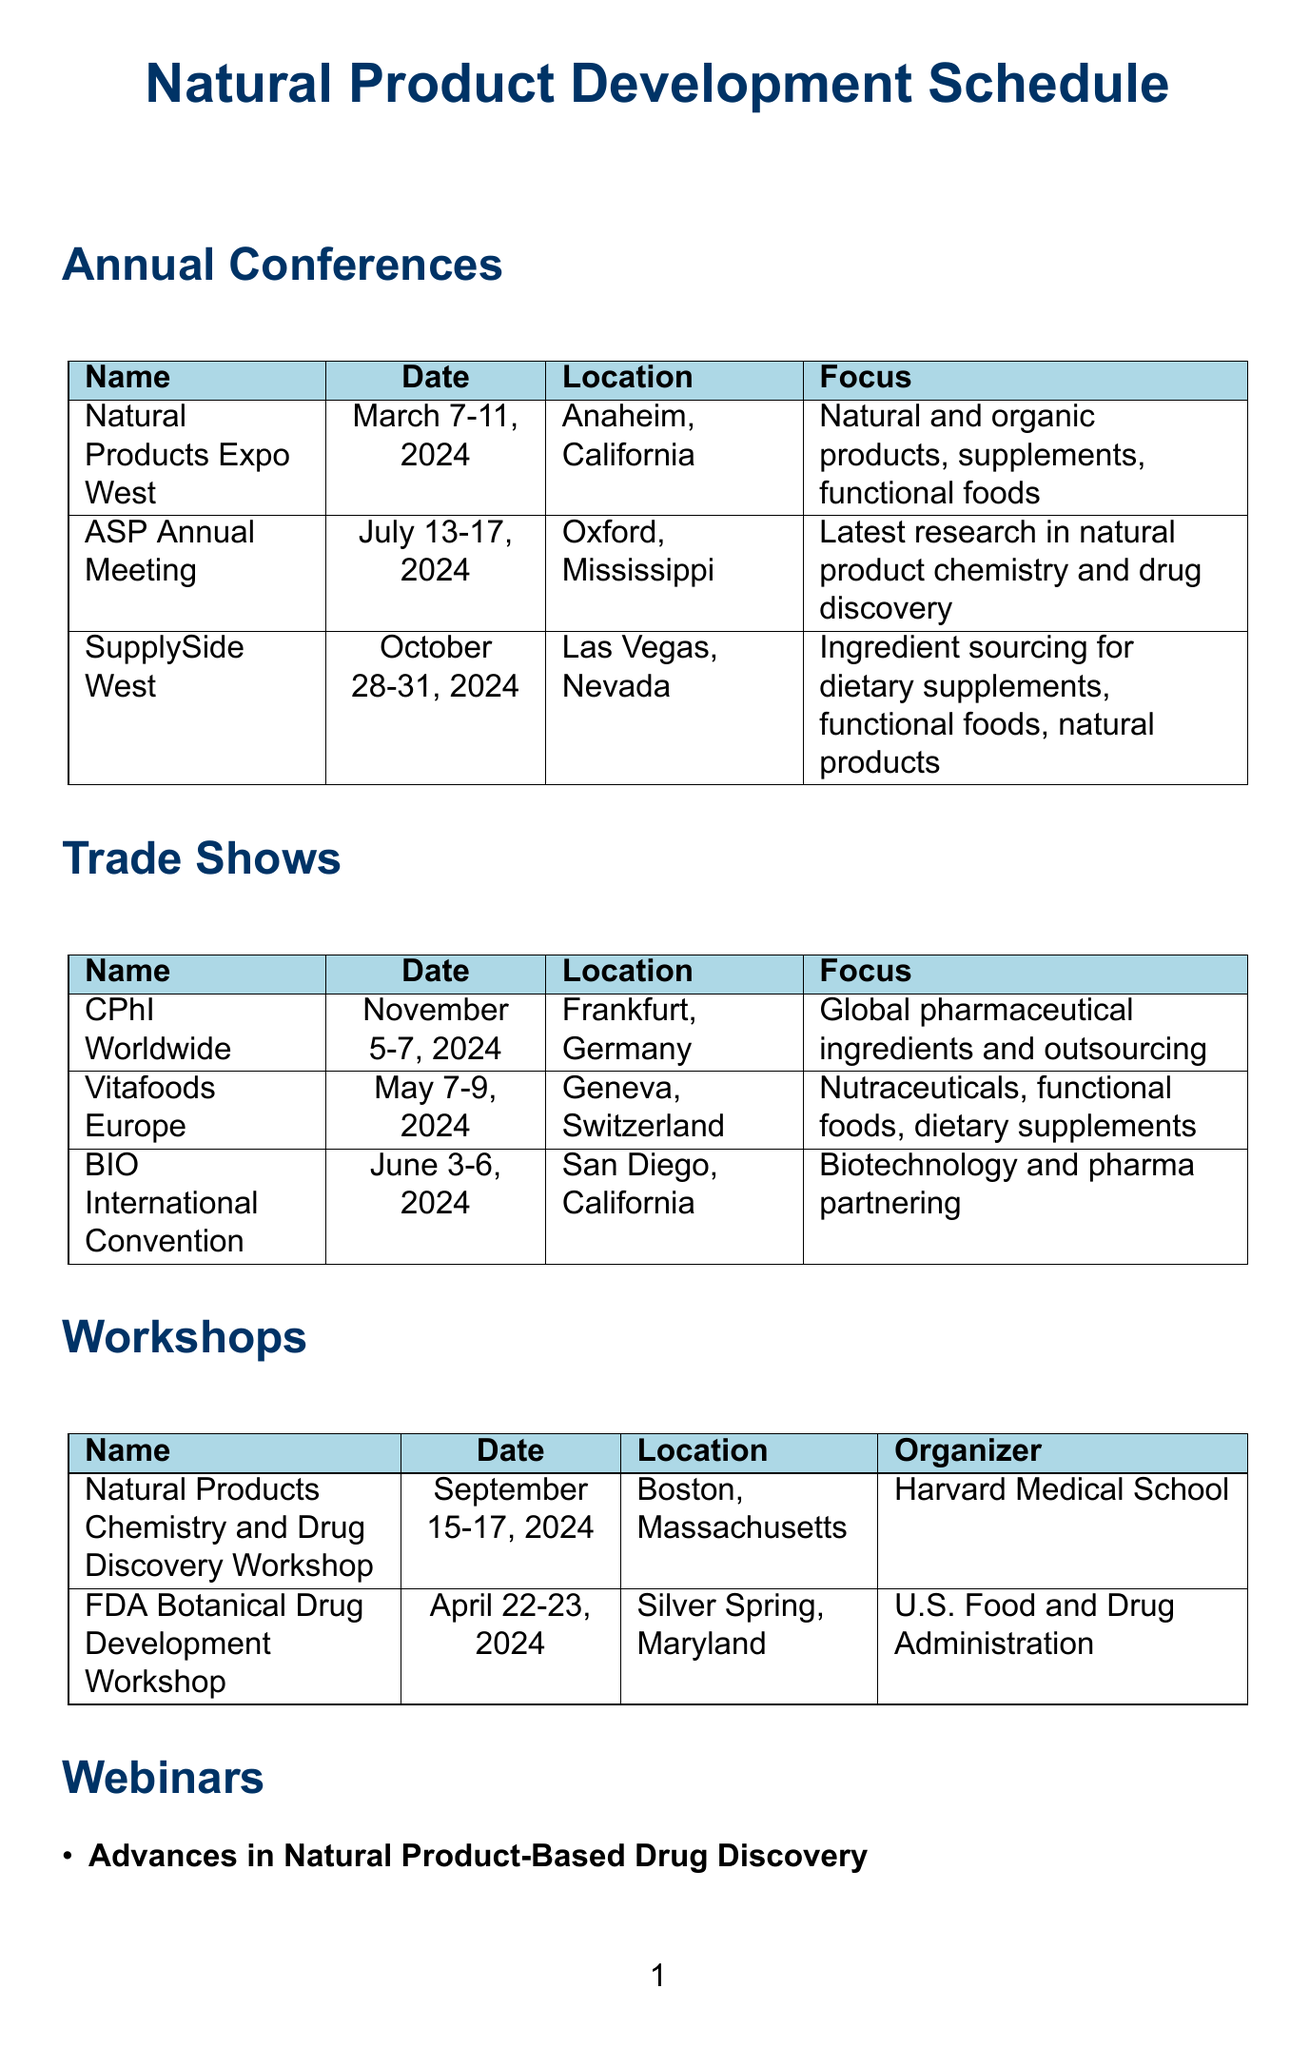What is the date for the Natural Products Expo West? The date for the Natural Products Expo West is specified in the schedule as March 7-11, 2024.
Answer: March 7-11, 2024 Where is the FDA Botanical Drug Development Workshop held? The document states that the FDA Botanical Drug Development Workshop will take place in Silver Spring, Maryland.
Answer: Silver Spring, Maryland What is the main focus of the SupplySide West? The focus of SupplySide West is described in the document as ingredient sourcing for dietary supplements, functional foods, and natural products.
Answer: Ingredient sourcing for dietary supplements, functional foods, and natural products Which organization is hosting the Natural Products Chemistry and Drug Discovery Workshop? The document indicates that Harvard Medical School is the organizer of the Natural Products Chemistry and Drug Discovery Workshop.
Answer: Harvard Medical School How often is the webinar on Advances in Natural Product-Based Drug Discovery held? The schedule specifies that the webinar on Advances in Natural Product-Based Drug Discovery is held monthly, on the last Thursday.
Answer: Monthly, last Thursday What is the location for the BIO International Convention? The document states that the BIO International Convention will take place in San Diego, California.
Answer: San Diego, California How many annual conferences are listed in the document? The document lists a total of three annual conferences.
Answer: Three What is the primary relevance of Vitafoods Europe? The document describes the relevance of Vitafoods Europe as important for exploring natural ingredients with potential pharmaceutical applications.
Answer: Important for exploring natural ingredients with potential pharmaceutical applications Which month is the first Tuesday for the Sustainable Sourcing webinar? The schedule states that the Sustainable Sourcing of Natural Ingredients for Pharmaceuticals webinar occurs quarterly on the first Tuesday, with no specific month mentioned; hence can be interpreted as every quarter starting January, April, July, or October.
Answer: Quarterly, first Tuesday 